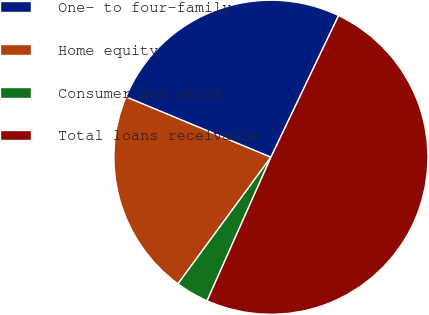<chart> <loc_0><loc_0><loc_500><loc_500><pie_chart><fcel>One- to four-family<fcel>Home equity<fcel>Consumer and other<fcel>Total loans receivable<nl><fcel>25.81%<fcel>21.2%<fcel>3.42%<fcel>49.57%<nl></chart> 